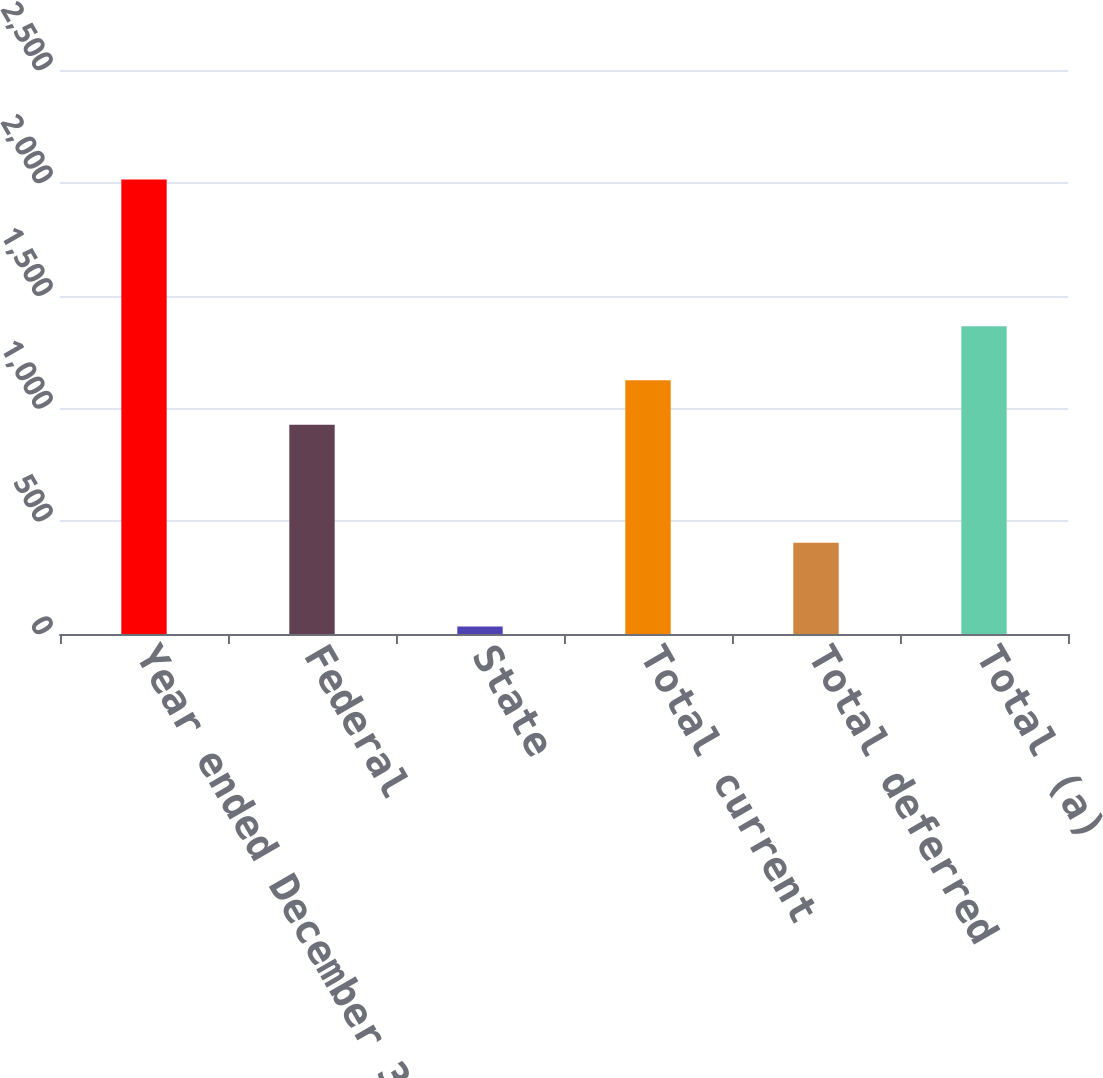<chart> <loc_0><loc_0><loc_500><loc_500><bar_chart><fcel>Year ended December 31 In<fcel>Federal<fcel>State<fcel>Total current<fcel>Total deferred<fcel>Total (a)<nl><fcel>2015<fcel>927<fcel>33<fcel>1125.2<fcel>404<fcel>1364<nl></chart> 